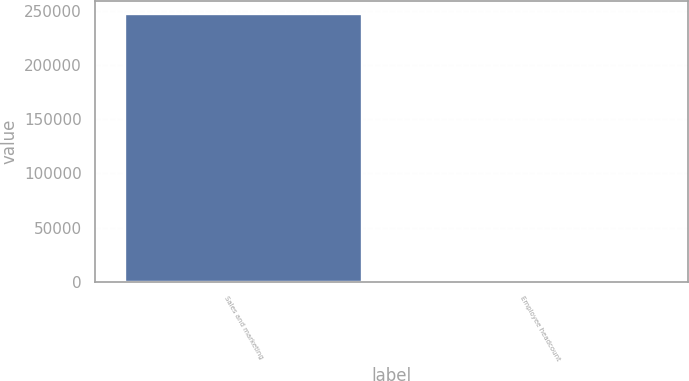<chart> <loc_0><loc_0><loc_500><loc_500><bar_chart><fcel>Sales and marketing<fcel>Employee headcount<nl><fcel>246659<fcel>656<nl></chart> 